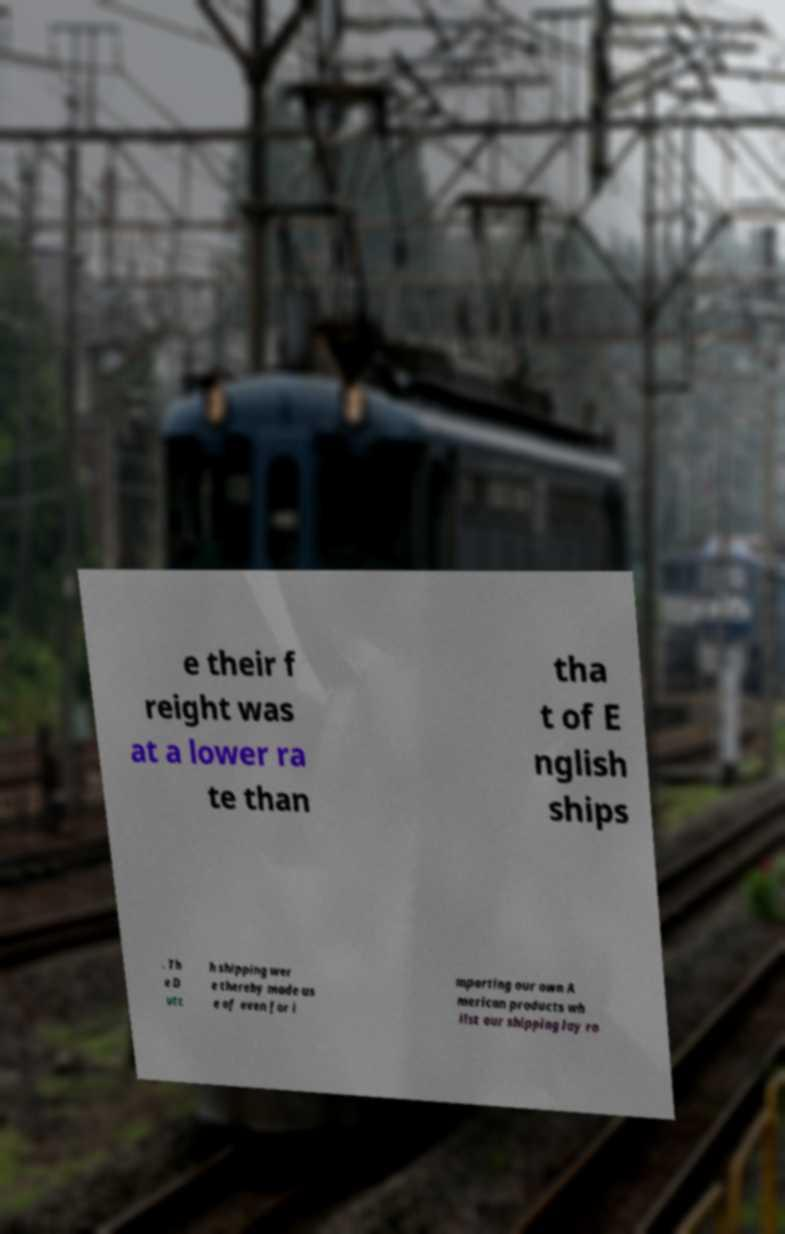Please identify and transcribe the text found in this image. e their f reight was at a lower ra te than tha t of E nglish ships . Th e D utc h shipping wer e thereby made us e of even for i mporting our own A merican products wh ilst our shipping lay ro 